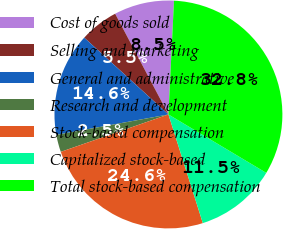<chart> <loc_0><loc_0><loc_500><loc_500><pie_chart><fcel>Cost of goods sold<fcel>Selling and marketing<fcel>General and administrative<fcel>Research and development<fcel>Stock-based compensation<fcel>Capitalized stock-based<fcel>Total stock-based compensation<nl><fcel>8.52%<fcel>5.49%<fcel>14.64%<fcel>2.45%<fcel>24.56%<fcel>11.55%<fcel>32.79%<nl></chart> 